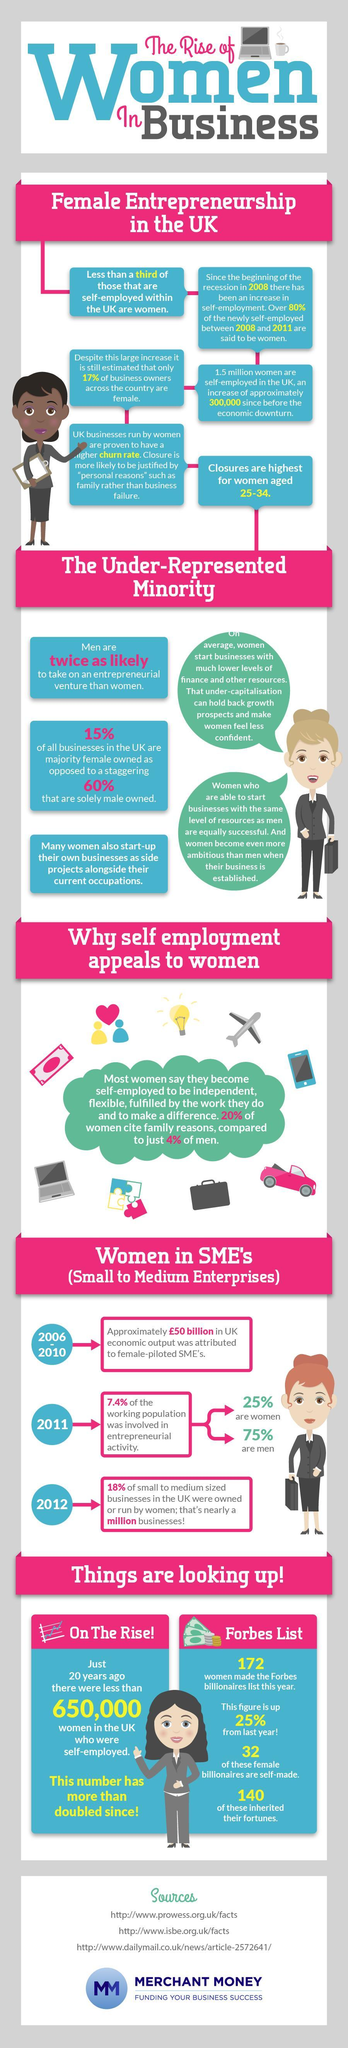What percentage of the working population in the UK who are involved in entrepreneurial activity are women in 2011?
Answer the question with a short phrase. 25% 